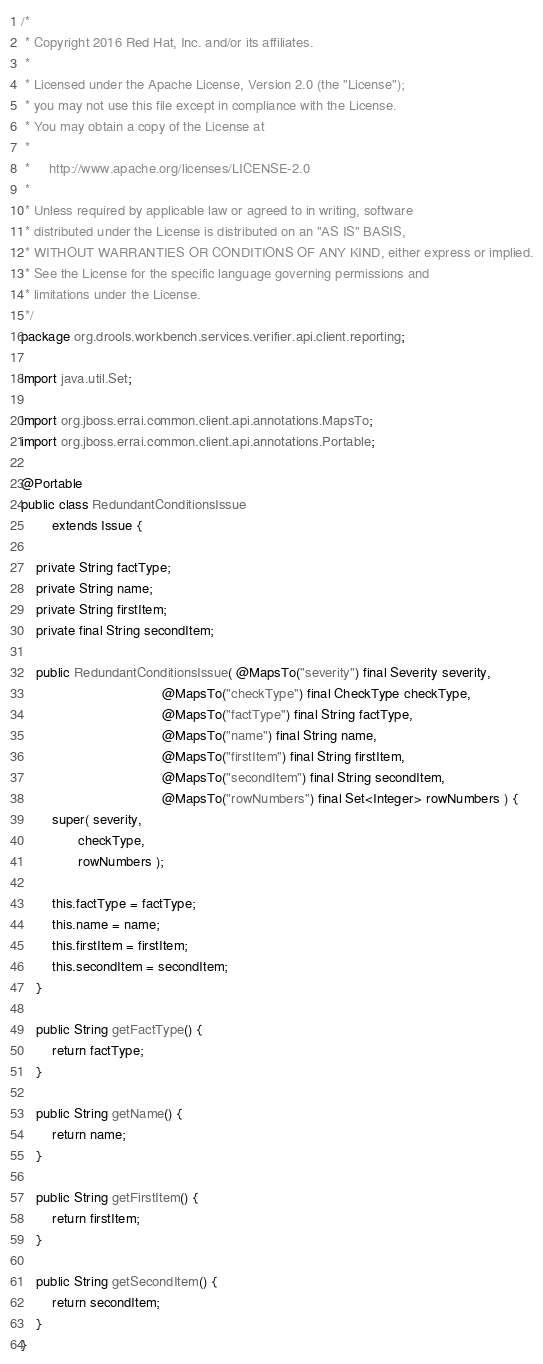<code> <loc_0><loc_0><loc_500><loc_500><_Java_>/*
 * Copyright 2016 Red Hat, Inc. and/or its affiliates.
 *
 * Licensed under the Apache License, Version 2.0 (the "License");
 * you may not use this file except in compliance with the License.
 * You may obtain a copy of the License at
 *
 *     http://www.apache.org/licenses/LICENSE-2.0
 *
 * Unless required by applicable law or agreed to in writing, software
 * distributed under the License is distributed on an "AS IS" BASIS,
 * WITHOUT WARRANTIES OR CONDITIONS OF ANY KIND, either express or implied.
 * See the License for the specific language governing permissions and
 * limitations under the License.
 */
package org.drools.workbench.services.verifier.api.client.reporting;

import java.util.Set;

import org.jboss.errai.common.client.api.annotations.MapsTo;
import org.jboss.errai.common.client.api.annotations.Portable;

@Portable
public class RedundantConditionsIssue
        extends Issue {

    private String factType;
    private String name;
    private String firstItem;
    private final String secondItem;

    public RedundantConditionsIssue( @MapsTo("severity") final Severity severity,
                                     @MapsTo("checkType") final CheckType checkType,
                                     @MapsTo("factType") final String factType,
                                     @MapsTo("name") final String name,
                                     @MapsTo("firstItem") final String firstItem,
                                     @MapsTo("secondItem") final String secondItem,
                                     @MapsTo("rowNumbers") final Set<Integer> rowNumbers ) {
        super( severity,
               checkType,
               rowNumbers );

        this.factType = factType;
        this.name = name;
        this.firstItem = firstItem;
        this.secondItem = secondItem;
    }

    public String getFactType() {
        return factType;
    }

    public String getName() {
        return name;
    }

    public String getFirstItem() {
        return firstItem;
    }

    public String getSecondItem() {
        return secondItem;
    }
}
</code> 